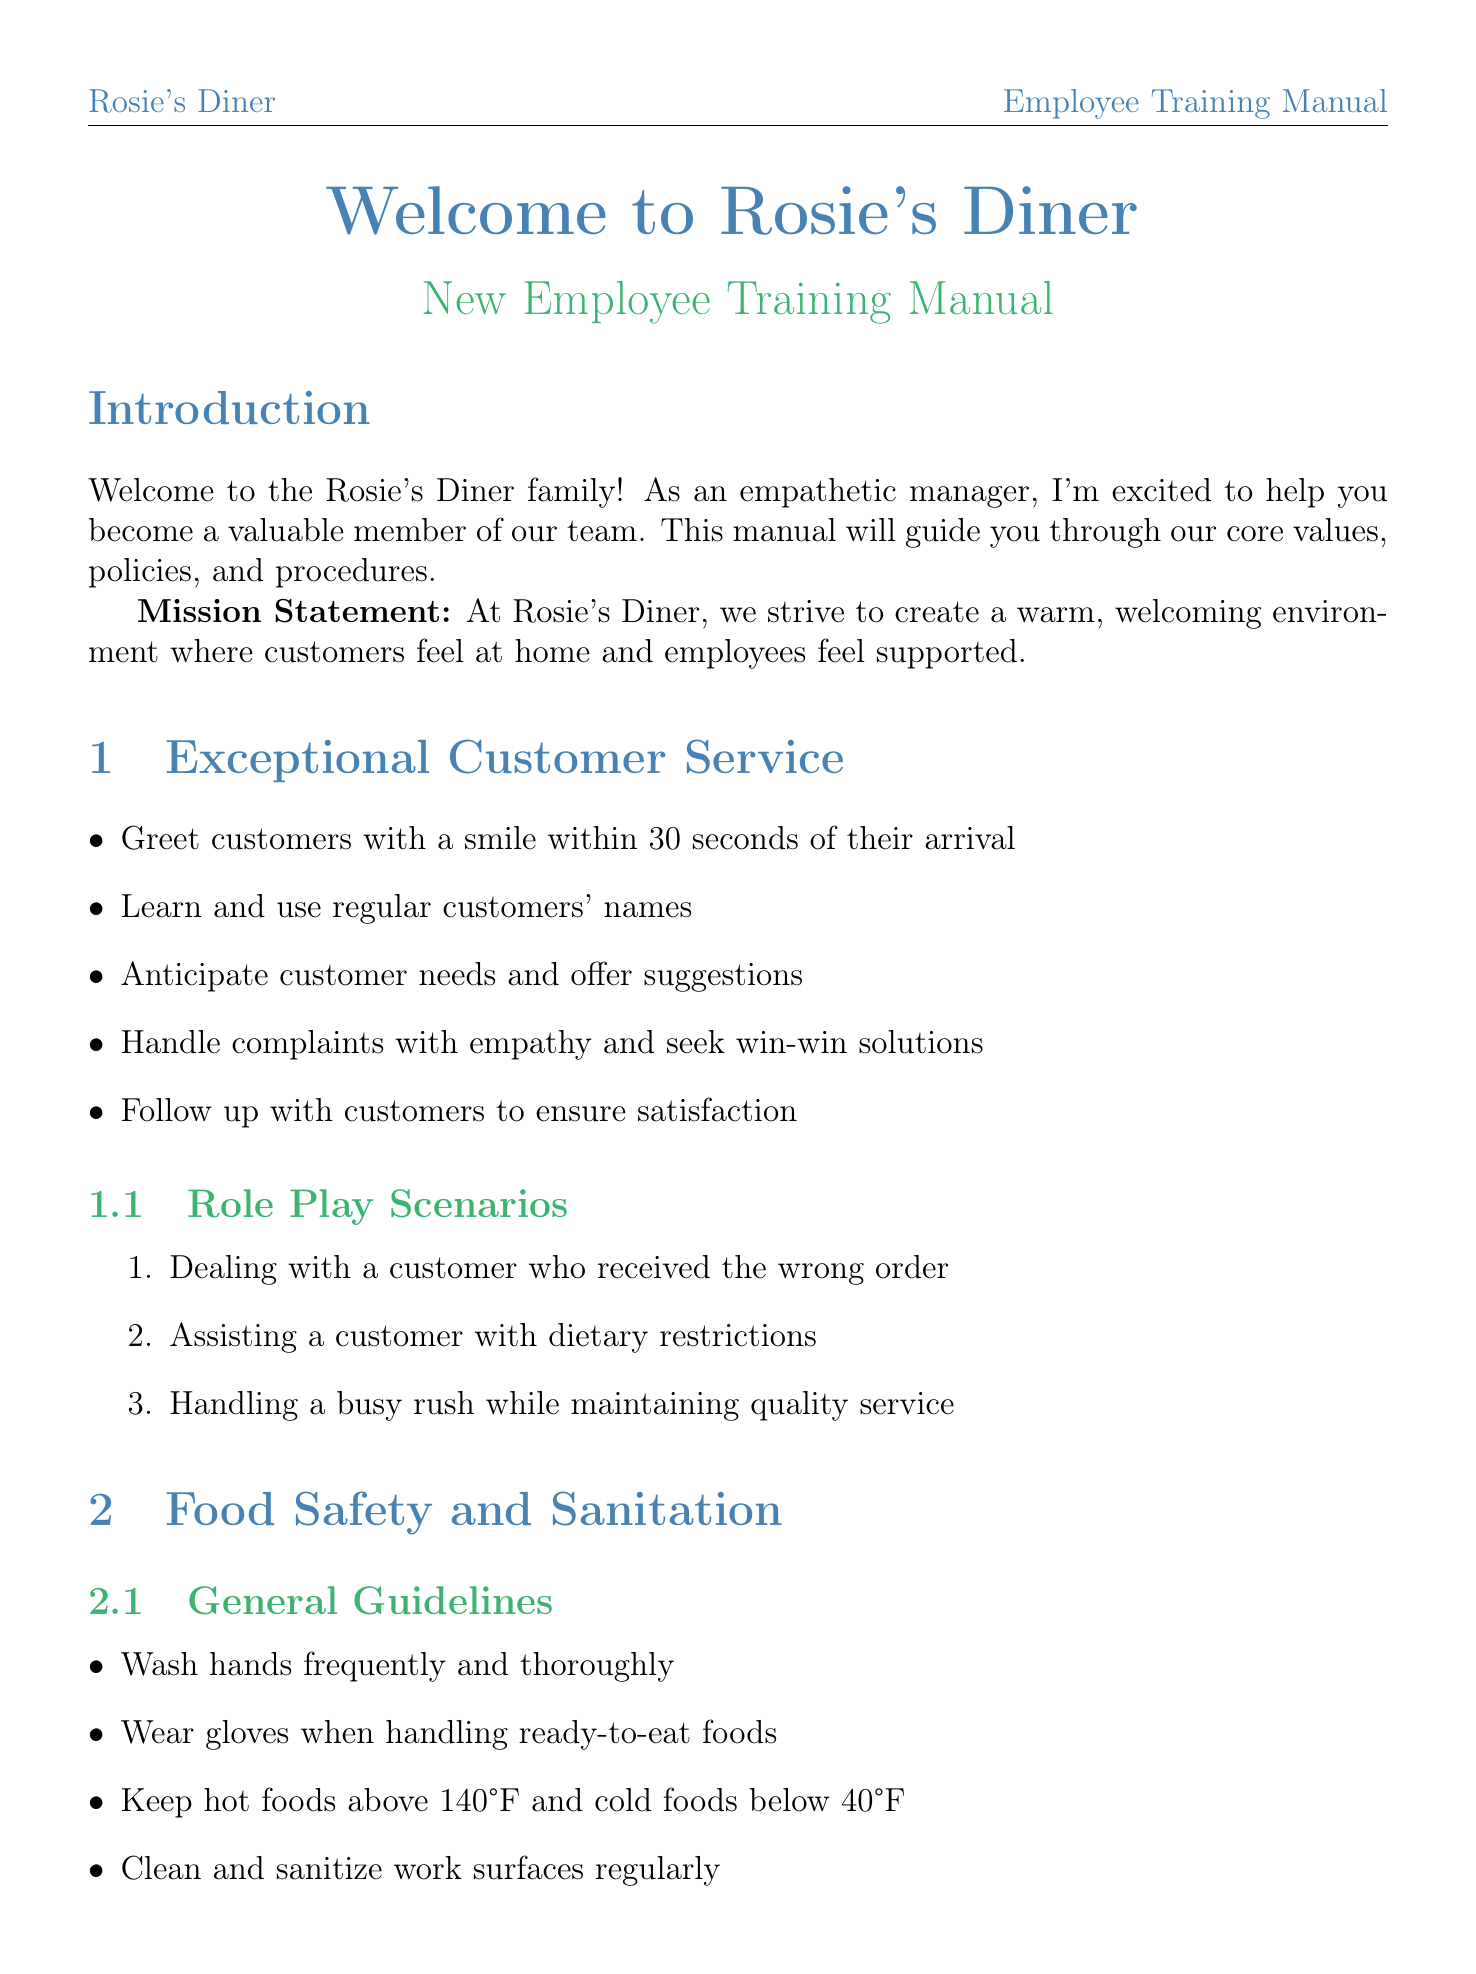What is the mission statement of Rosie's Diner? The mission statement outlines the core values of Rosie's Diner, emphasizing a warm environment for customers and support for employees.
Answer: A warm, welcoming environment where customers feel at home and employees feel supported How often are health inspections conducted? The document states the frequency of health inspections required for the diner.
Answer: Twice annually What should be done when a customer has a dietary restriction? This refers to one of the role play scenarios designed to help staff understand how to assist customers with specific needs.
Answer: Assisting a customer with dietary restrictions What is the temperature requirement for hot foods? This refers to guidelines in the food safety section regarding food temperatures for safety.
Answer: Above 140°F List two common allergens mentioned in the food safety section. This question asks for specific information from the allergens section, which lists several common food allergies.
Answer: Milk, eggs 